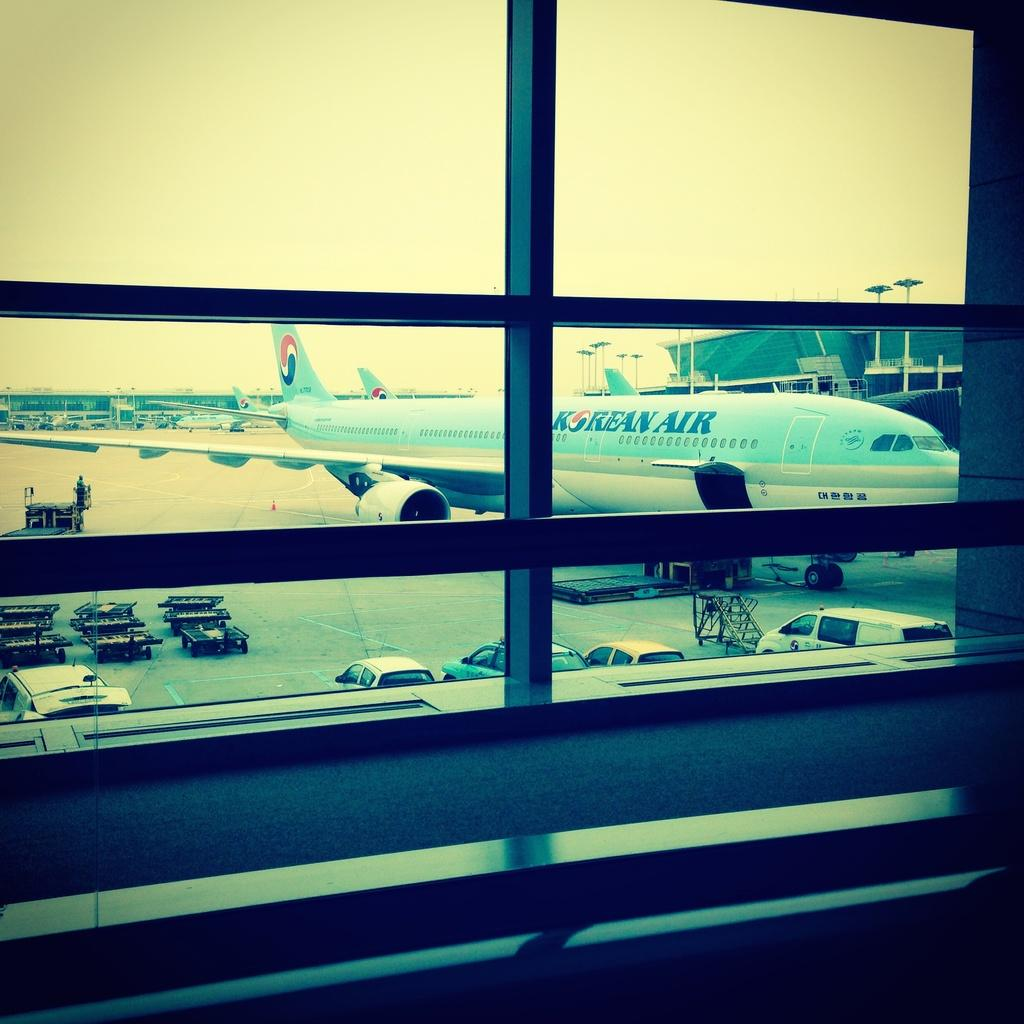Provide a one-sentence caption for the provided image. an airport window looking out at a Korean Air at a gate. 